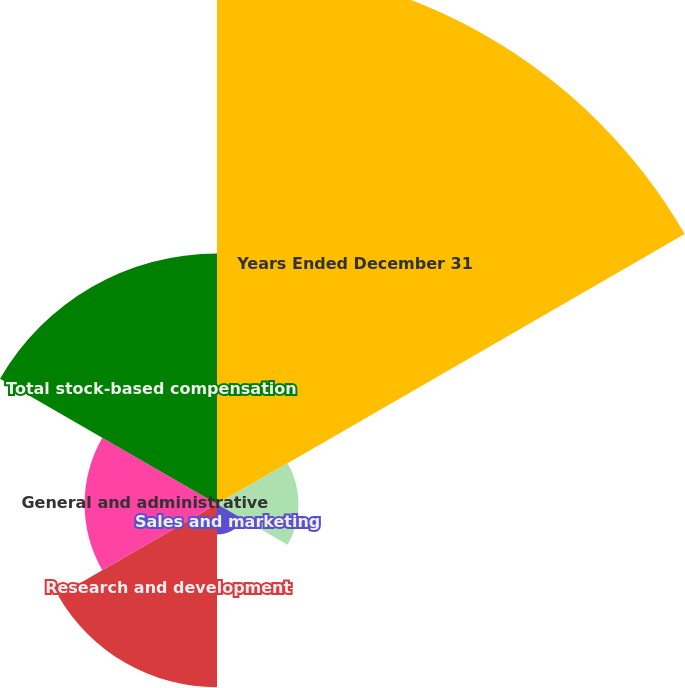Convert chart to OTSL. <chart><loc_0><loc_0><loc_500><loc_500><pie_chart><fcel>Years Ended December 31<fcel>Operating expense<fcel>Sales and marketing<fcel>Research and development<fcel>General and administrative<fcel>Total stock-based compensation<nl><fcel>44.32%<fcel>6.69%<fcel>2.51%<fcel>15.05%<fcel>10.87%<fcel>20.56%<nl></chart> 